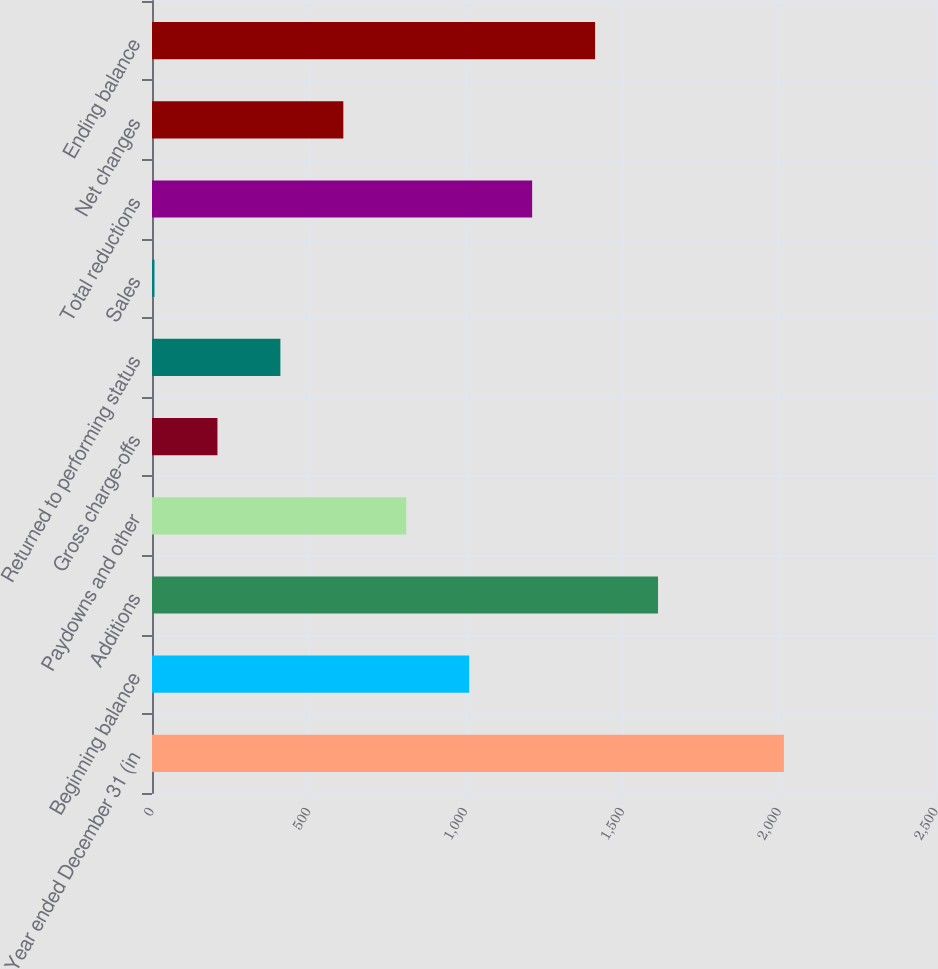Convert chart to OTSL. <chart><loc_0><loc_0><loc_500><loc_500><bar_chart><fcel>Year ended December 31 (in<fcel>Beginning balance<fcel>Additions<fcel>Paydowns and other<fcel>Gross charge-offs<fcel>Returned to performing status<fcel>Sales<fcel>Total reductions<fcel>Net changes<fcel>Ending balance<nl><fcel>2015<fcel>1011.5<fcel>1613.6<fcel>810.8<fcel>208.7<fcel>409.4<fcel>8<fcel>1212.2<fcel>610.1<fcel>1412.9<nl></chart> 